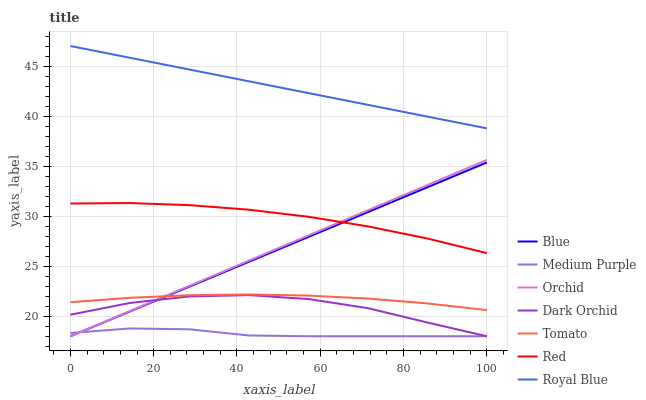Does Medium Purple have the minimum area under the curve?
Answer yes or no. Yes. Does Royal Blue have the maximum area under the curve?
Answer yes or no. Yes. Does Tomato have the minimum area under the curve?
Answer yes or no. No. Does Tomato have the maximum area under the curve?
Answer yes or no. No. Is Royal Blue the smoothest?
Answer yes or no. Yes. Is Dark Orchid the roughest?
Answer yes or no. Yes. Is Tomato the smoothest?
Answer yes or no. No. Is Tomato the roughest?
Answer yes or no. No. Does Tomato have the lowest value?
Answer yes or no. No. Does Tomato have the highest value?
Answer yes or no. No. Is Red less than Royal Blue?
Answer yes or no. Yes. Is Red greater than Medium Purple?
Answer yes or no. Yes. Does Red intersect Royal Blue?
Answer yes or no. No. 